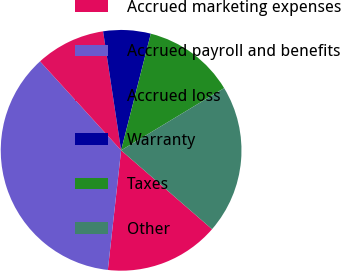Convert chart to OTSL. <chart><loc_0><loc_0><loc_500><loc_500><pie_chart><fcel>Accrued marketing expenses<fcel>Accrued payroll and benefits<fcel>Accrued loss<fcel>Warranty<fcel>Taxes<fcel>Other<nl><fcel>15.39%<fcel>36.48%<fcel>9.37%<fcel>6.36%<fcel>12.38%<fcel>20.02%<nl></chart> 